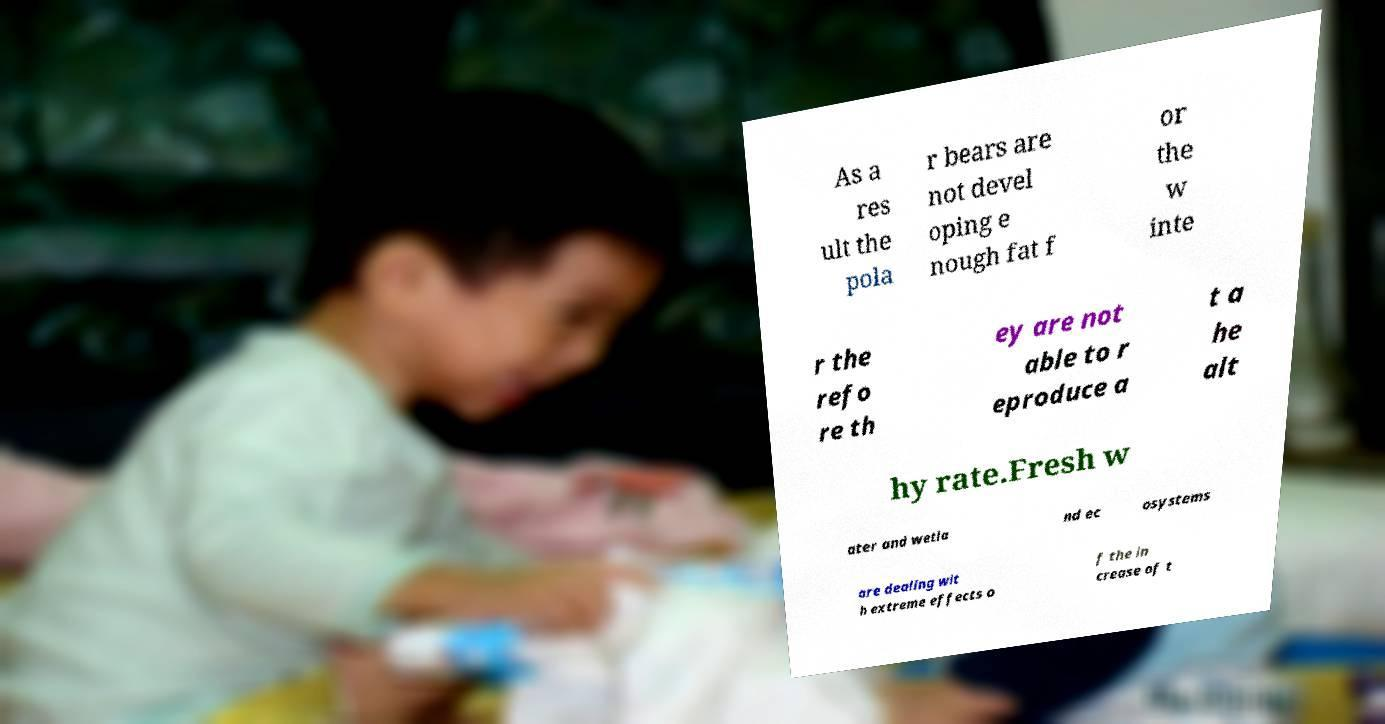Could you assist in decoding the text presented in this image and type it out clearly? As a res ult the pola r bears are not devel oping e nough fat f or the w inte r the refo re th ey are not able to r eproduce a t a he alt hy rate.Fresh w ater and wetla nd ec osystems are dealing wit h extreme effects o f the in crease of t 